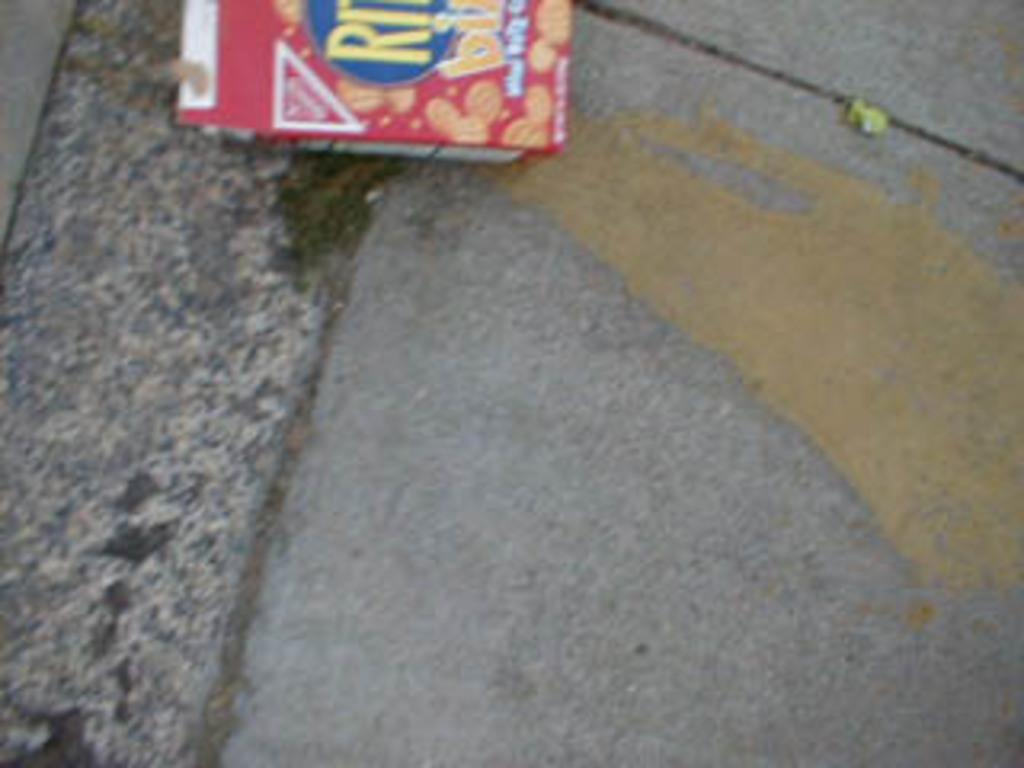How would you summarize this image in a sentence or two? In this image, we can see an object on the ground. 